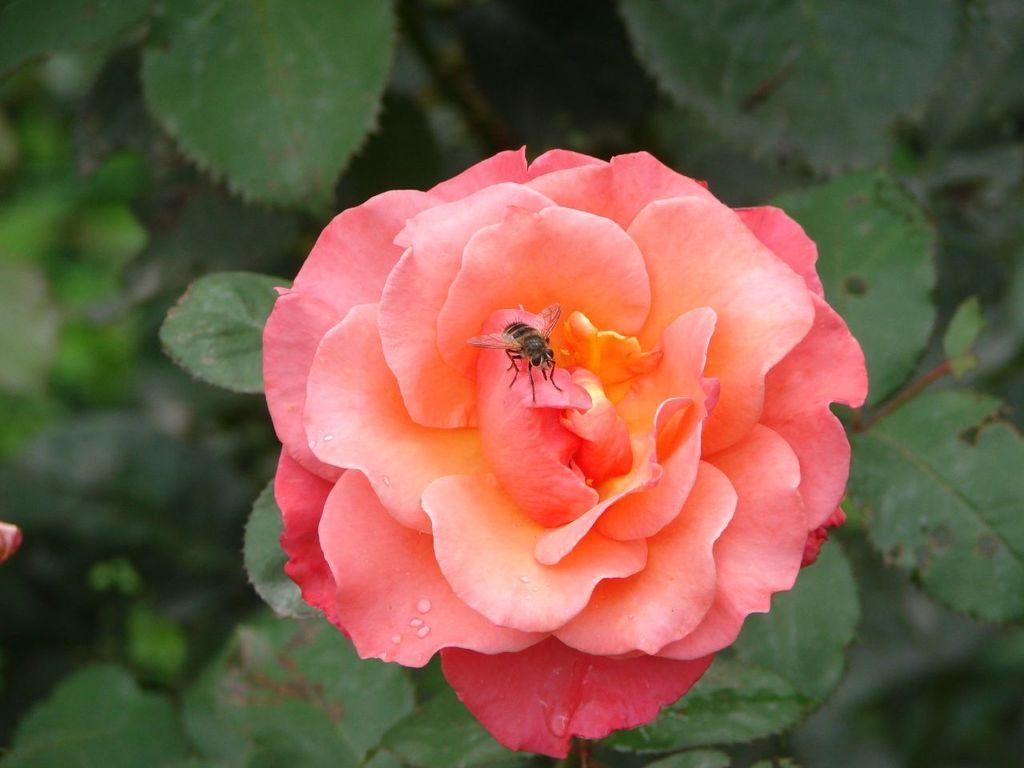In one or two sentences, can you explain what this image depicts? In this image we can see a fly on the flower. 